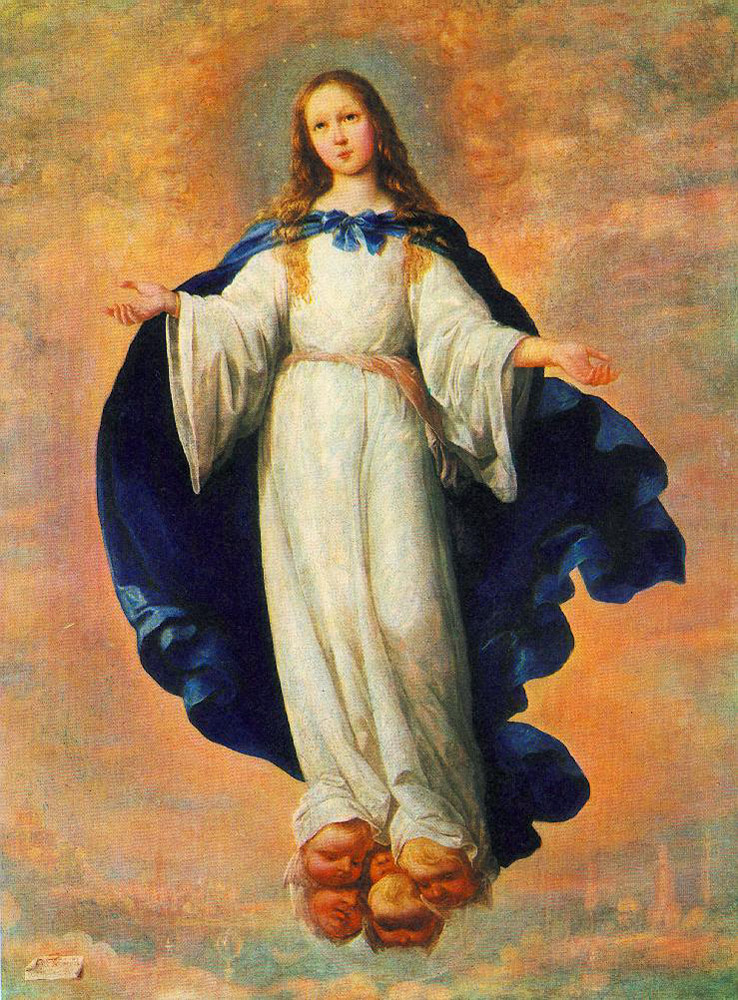What do you think is going on in this snapshot? The image depicts a young girl wearing a white dress and a blue cloak, seemingly floating gracefully in the sky. Her long blonde hair cascades down her shoulders, and she meets the viewer's gaze, establishing a sense of direct connection. The background features a cloudy sky with a cityscape below, giving the scene depth and a surreal quality. The meticulous details and the realistic art style suggest a religious theme, perhaps alluding to a divine or angelic figure. The ethereal ambiance created by her pose and the surrounding heavenly backdrop enhances this spiritual impression. 